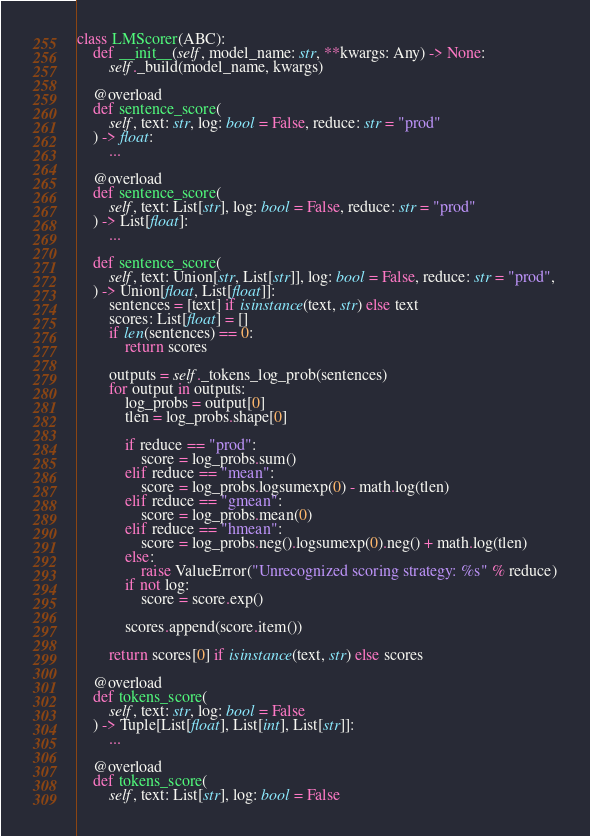<code> <loc_0><loc_0><loc_500><loc_500><_Python_>
class LMScorer(ABC):
    def __init__(self, model_name: str, **kwargs: Any) -> None:
        self._build(model_name, kwargs)

    @overload
    def sentence_score(
        self, text: str, log: bool = False, reduce: str = "prod"
    ) -> float:
        ...

    @overload
    def sentence_score(
        self, text: List[str], log: bool = False, reduce: str = "prod"
    ) -> List[float]:
        ...

    def sentence_score(
        self, text: Union[str, List[str]], log: bool = False, reduce: str = "prod",
    ) -> Union[float, List[float]]:
        sentences = [text] if isinstance(text, str) else text
        scores: List[float] = []
        if len(sentences) == 0:
            return scores

        outputs = self._tokens_log_prob(sentences)
        for output in outputs:
            log_probs = output[0]
            tlen = log_probs.shape[0]

            if reduce == "prod":
                score = log_probs.sum()
            elif reduce == "mean":
                score = log_probs.logsumexp(0) - math.log(tlen)
            elif reduce == "gmean":
                score = log_probs.mean(0)
            elif reduce == "hmean":
                score = log_probs.neg().logsumexp(0).neg() + math.log(tlen)
            else:
                raise ValueError("Unrecognized scoring strategy: %s" % reduce)
            if not log:
                score = score.exp()

            scores.append(score.item())

        return scores[0] if isinstance(text, str) else scores

    @overload
    def tokens_score(
        self, text: str, log: bool = False
    ) -> Tuple[List[float], List[int], List[str]]:
        ...

    @overload
    def tokens_score(
        self, text: List[str], log: bool = False</code> 